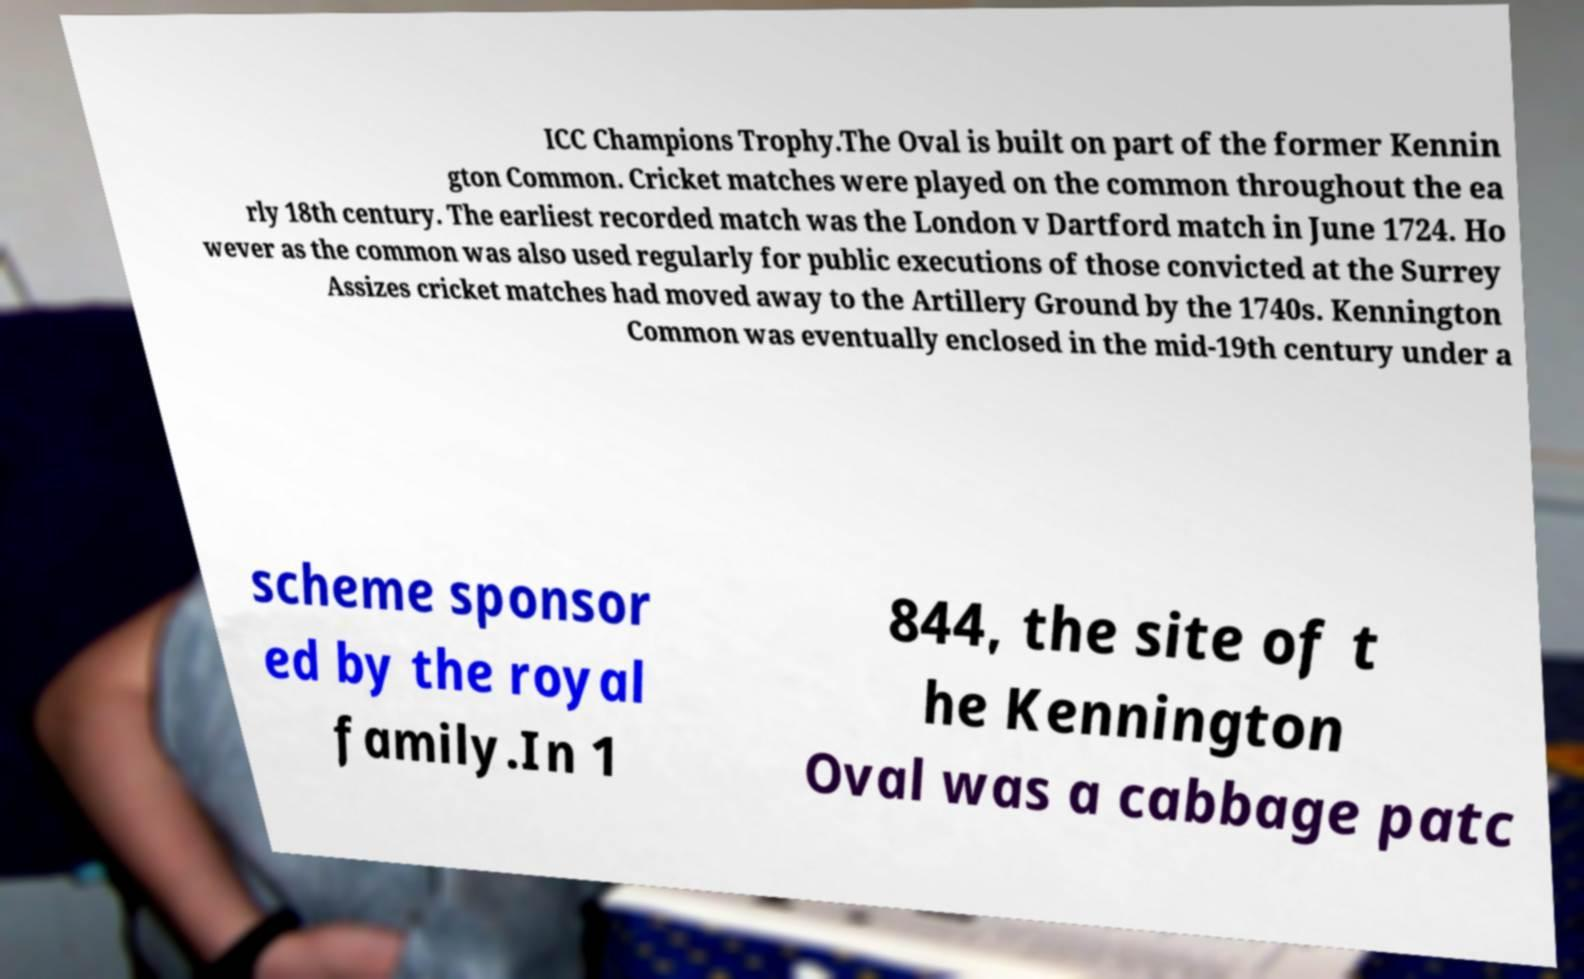Can you read and provide the text displayed in the image?This photo seems to have some interesting text. Can you extract and type it out for me? ICC Champions Trophy.The Oval is built on part of the former Kennin gton Common. Cricket matches were played on the common throughout the ea rly 18th century. The earliest recorded match was the London v Dartford match in June 1724. Ho wever as the common was also used regularly for public executions of those convicted at the Surrey Assizes cricket matches had moved away to the Artillery Ground by the 1740s. Kennington Common was eventually enclosed in the mid-19th century under a scheme sponsor ed by the royal family.In 1 844, the site of t he Kennington Oval was a cabbage patc 